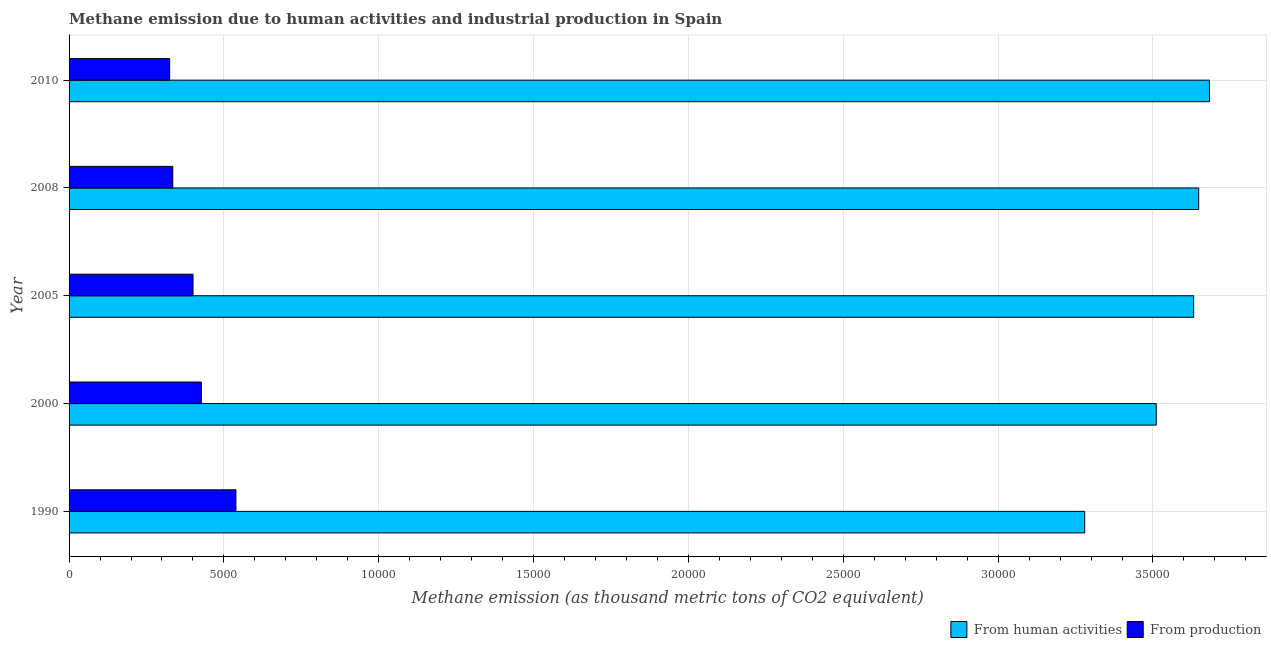Are the number of bars per tick equal to the number of legend labels?
Your answer should be compact. Yes. Are the number of bars on each tick of the Y-axis equal?
Keep it short and to the point. Yes. How many bars are there on the 5th tick from the bottom?
Your answer should be very brief. 2. What is the label of the 5th group of bars from the top?
Provide a short and direct response. 1990. In how many cases, is the number of bars for a given year not equal to the number of legend labels?
Ensure brevity in your answer.  0. What is the amount of emissions from human activities in 2000?
Provide a short and direct response. 3.51e+04. Across all years, what is the maximum amount of emissions from human activities?
Ensure brevity in your answer.  3.68e+04. Across all years, what is the minimum amount of emissions generated from industries?
Make the answer very short. 3248.1. In which year was the amount of emissions from human activities maximum?
Your response must be concise. 2010. In which year was the amount of emissions from human activities minimum?
Ensure brevity in your answer.  1990. What is the total amount of emissions from human activities in the graph?
Offer a terse response. 1.78e+05. What is the difference between the amount of emissions from human activities in 2005 and that in 2010?
Your answer should be very brief. -510. What is the difference between the amount of emissions from human activities in 2008 and the amount of emissions generated from industries in 2010?
Keep it short and to the point. 3.32e+04. What is the average amount of emissions from human activities per year?
Ensure brevity in your answer.  3.55e+04. In the year 2000, what is the difference between the amount of emissions generated from industries and amount of emissions from human activities?
Your answer should be very brief. -3.08e+04. In how many years, is the amount of emissions generated from industries greater than 21000 thousand metric tons?
Ensure brevity in your answer.  0. Is the amount of emissions generated from industries in 2000 less than that in 2008?
Your response must be concise. No. What is the difference between the highest and the second highest amount of emissions generated from industries?
Provide a succinct answer. 1116.8. What is the difference between the highest and the lowest amount of emissions generated from industries?
Provide a short and direct response. 2139.7. In how many years, is the amount of emissions from human activities greater than the average amount of emissions from human activities taken over all years?
Make the answer very short. 3. What does the 1st bar from the top in 2010 represents?
Ensure brevity in your answer.  From production. What does the 1st bar from the bottom in 2010 represents?
Keep it short and to the point. From human activities. How many years are there in the graph?
Your answer should be very brief. 5. What is the difference between two consecutive major ticks on the X-axis?
Provide a short and direct response. 5000. Does the graph contain any zero values?
Your answer should be very brief. No. Does the graph contain grids?
Make the answer very short. Yes. How many legend labels are there?
Offer a very short reply. 2. How are the legend labels stacked?
Offer a very short reply. Horizontal. What is the title of the graph?
Your answer should be very brief. Methane emission due to human activities and industrial production in Spain. What is the label or title of the X-axis?
Ensure brevity in your answer.  Methane emission (as thousand metric tons of CO2 equivalent). What is the Methane emission (as thousand metric tons of CO2 equivalent) of From human activities in 1990?
Ensure brevity in your answer.  3.28e+04. What is the Methane emission (as thousand metric tons of CO2 equivalent) in From production in 1990?
Give a very brief answer. 5387.8. What is the Methane emission (as thousand metric tons of CO2 equivalent) in From human activities in 2000?
Offer a very short reply. 3.51e+04. What is the Methane emission (as thousand metric tons of CO2 equivalent) of From production in 2000?
Your response must be concise. 4271. What is the Methane emission (as thousand metric tons of CO2 equivalent) of From human activities in 2005?
Your answer should be compact. 3.63e+04. What is the Methane emission (as thousand metric tons of CO2 equivalent) of From production in 2005?
Make the answer very short. 4002.6. What is the Methane emission (as thousand metric tons of CO2 equivalent) in From human activities in 2008?
Make the answer very short. 3.65e+04. What is the Methane emission (as thousand metric tons of CO2 equivalent) in From production in 2008?
Provide a succinct answer. 3348.1. What is the Methane emission (as thousand metric tons of CO2 equivalent) in From human activities in 2010?
Offer a very short reply. 3.68e+04. What is the Methane emission (as thousand metric tons of CO2 equivalent) in From production in 2010?
Keep it short and to the point. 3248.1. Across all years, what is the maximum Methane emission (as thousand metric tons of CO2 equivalent) of From human activities?
Offer a very short reply. 3.68e+04. Across all years, what is the maximum Methane emission (as thousand metric tons of CO2 equivalent) in From production?
Your response must be concise. 5387.8. Across all years, what is the minimum Methane emission (as thousand metric tons of CO2 equivalent) in From human activities?
Ensure brevity in your answer.  3.28e+04. Across all years, what is the minimum Methane emission (as thousand metric tons of CO2 equivalent) in From production?
Offer a very short reply. 3248.1. What is the total Methane emission (as thousand metric tons of CO2 equivalent) in From human activities in the graph?
Keep it short and to the point. 1.78e+05. What is the total Methane emission (as thousand metric tons of CO2 equivalent) in From production in the graph?
Provide a short and direct response. 2.03e+04. What is the difference between the Methane emission (as thousand metric tons of CO2 equivalent) in From human activities in 1990 and that in 2000?
Keep it short and to the point. -2310.4. What is the difference between the Methane emission (as thousand metric tons of CO2 equivalent) in From production in 1990 and that in 2000?
Ensure brevity in your answer.  1116.8. What is the difference between the Methane emission (as thousand metric tons of CO2 equivalent) in From human activities in 1990 and that in 2005?
Ensure brevity in your answer.  -3519.1. What is the difference between the Methane emission (as thousand metric tons of CO2 equivalent) of From production in 1990 and that in 2005?
Provide a succinct answer. 1385.2. What is the difference between the Methane emission (as thousand metric tons of CO2 equivalent) in From human activities in 1990 and that in 2008?
Ensure brevity in your answer.  -3681.4. What is the difference between the Methane emission (as thousand metric tons of CO2 equivalent) of From production in 1990 and that in 2008?
Make the answer very short. 2039.7. What is the difference between the Methane emission (as thousand metric tons of CO2 equivalent) of From human activities in 1990 and that in 2010?
Your answer should be very brief. -4029.1. What is the difference between the Methane emission (as thousand metric tons of CO2 equivalent) of From production in 1990 and that in 2010?
Give a very brief answer. 2139.7. What is the difference between the Methane emission (as thousand metric tons of CO2 equivalent) in From human activities in 2000 and that in 2005?
Your response must be concise. -1208.7. What is the difference between the Methane emission (as thousand metric tons of CO2 equivalent) in From production in 2000 and that in 2005?
Offer a very short reply. 268.4. What is the difference between the Methane emission (as thousand metric tons of CO2 equivalent) in From human activities in 2000 and that in 2008?
Provide a succinct answer. -1371. What is the difference between the Methane emission (as thousand metric tons of CO2 equivalent) in From production in 2000 and that in 2008?
Your response must be concise. 922.9. What is the difference between the Methane emission (as thousand metric tons of CO2 equivalent) of From human activities in 2000 and that in 2010?
Your response must be concise. -1718.7. What is the difference between the Methane emission (as thousand metric tons of CO2 equivalent) in From production in 2000 and that in 2010?
Keep it short and to the point. 1022.9. What is the difference between the Methane emission (as thousand metric tons of CO2 equivalent) in From human activities in 2005 and that in 2008?
Keep it short and to the point. -162.3. What is the difference between the Methane emission (as thousand metric tons of CO2 equivalent) in From production in 2005 and that in 2008?
Provide a succinct answer. 654.5. What is the difference between the Methane emission (as thousand metric tons of CO2 equivalent) in From human activities in 2005 and that in 2010?
Ensure brevity in your answer.  -510. What is the difference between the Methane emission (as thousand metric tons of CO2 equivalent) in From production in 2005 and that in 2010?
Provide a succinct answer. 754.5. What is the difference between the Methane emission (as thousand metric tons of CO2 equivalent) of From human activities in 2008 and that in 2010?
Provide a short and direct response. -347.7. What is the difference between the Methane emission (as thousand metric tons of CO2 equivalent) in From human activities in 1990 and the Methane emission (as thousand metric tons of CO2 equivalent) in From production in 2000?
Your response must be concise. 2.85e+04. What is the difference between the Methane emission (as thousand metric tons of CO2 equivalent) in From human activities in 1990 and the Methane emission (as thousand metric tons of CO2 equivalent) in From production in 2005?
Provide a succinct answer. 2.88e+04. What is the difference between the Methane emission (as thousand metric tons of CO2 equivalent) of From human activities in 1990 and the Methane emission (as thousand metric tons of CO2 equivalent) of From production in 2008?
Provide a succinct answer. 2.94e+04. What is the difference between the Methane emission (as thousand metric tons of CO2 equivalent) of From human activities in 1990 and the Methane emission (as thousand metric tons of CO2 equivalent) of From production in 2010?
Your answer should be compact. 2.95e+04. What is the difference between the Methane emission (as thousand metric tons of CO2 equivalent) of From human activities in 2000 and the Methane emission (as thousand metric tons of CO2 equivalent) of From production in 2005?
Give a very brief answer. 3.11e+04. What is the difference between the Methane emission (as thousand metric tons of CO2 equivalent) in From human activities in 2000 and the Methane emission (as thousand metric tons of CO2 equivalent) in From production in 2008?
Your response must be concise. 3.18e+04. What is the difference between the Methane emission (as thousand metric tons of CO2 equivalent) of From human activities in 2000 and the Methane emission (as thousand metric tons of CO2 equivalent) of From production in 2010?
Your answer should be compact. 3.19e+04. What is the difference between the Methane emission (as thousand metric tons of CO2 equivalent) of From human activities in 2005 and the Methane emission (as thousand metric tons of CO2 equivalent) of From production in 2008?
Make the answer very short. 3.30e+04. What is the difference between the Methane emission (as thousand metric tons of CO2 equivalent) in From human activities in 2005 and the Methane emission (as thousand metric tons of CO2 equivalent) in From production in 2010?
Keep it short and to the point. 3.31e+04. What is the difference between the Methane emission (as thousand metric tons of CO2 equivalent) of From human activities in 2008 and the Methane emission (as thousand metric tons of CO2 equivalent) of From production in 2010?
Your answer should be compact. 3.32e+04. What is the average Methane emission (as thousand metric tons of CO2 equivalent) of From human activities per year?
Ensure brevity in your answer.  3.55e+04. What is the average Methane emission (as thousand metric tons of CO2 equivalent) in From production per year?
Make the answer very short. 4051.52. In the year 1990, what is the difference between the Methane emission (as thousand metric tons of CO2 equivalent) in From human activities and Methane emission (as thousand metric tons of CO2 equivalent) in From production?
Provide a succinct answer. 2.74e+04. In the year 2000, what is the difference between the Methane emission (as thousand metric tons of CO2 equivalent) in From human activities and Methane emission (as thousand metric tons of CO2 equivalent) in From production?
Your answer should be compact. 3.08e+04. In the year 2005, what is the difference between the Methane emission (as thousand metric tons of CO2 equivalent) of From human activities and Methane emission (as thousand metric tons of CO2 equivalent) of From production?
Provide a succinct answer. 3.23e+04. In the year 2008, what is the difference between the Methane emission (as thousand metric tons of CO2 equivalent) in From human activities and Methane emission (as thousand metric tons of CO2 equivalent) in From production?
Your response must be concise. 3.31e+04. In the year 2010, what is the difference between the Methane emission (as thousand metric tons of CO2 equivalent) in From human activities and Methane emission (as thousand metric tons of CO2 equivalent) in From production?
Your answer should be compact. 3.36e+04. What is the ratio of the Methane emission (as thousand metric tons of CO2 equivalent) in From human activities in 1990 to that in 2000?
Offer a very short reply. 0.93. What is the ratio of the Methane emission (as thousand metric tons of CO2 equivalent) in From production in 1990 to that in 2000?
Your response must be concise. 1.26. What is the ratio of the Methane emission (as thousand metric tons of CO2 equivalent) in From human activities in 1990 to that in 2005?
Give a very brief answer. 0.9. What is the ratio of the Methane emission (as thousand metric tons of CO2 equivalent) in From production in 1990 to that in 2005?
Offer a very short reply. 1.35. What is the ratio of the Methane emission (as thousand metric tons of CO2 equivalent) of From human activities in 1990 to that in 2008?
Offer a terse response. 0.9. What is the ratio of the Methane emission (as thousand metric tons of CO2 equivalent) of From production in 1990 to that in 2008?
Ensure brevity in your answer.  1.61. What is the ratio of the Methane emission (as thousand metric tons of CO2 equivalent) in From human activities in 1990 to that in 2010?
Your answer should be very brief. 0.89. What is the ratio of the Methane emission (as thousand metric tons of CO2 equivalent) of From production in 1990 to that in 2010?
Your response must be concise. 1.66. What is the ratio of the Methane emission (as thousand metric tons of CO2 equivalent) of From human activities in 2000 to that in 2005?
Provide a short and direct response. 0.97. What is the ratio of the Methane emission (as thousand metric tons of CO2 equivalent) of From production in 2000 to that in 2005?
Your answer should be very brief. 1.07. What is the ratio of the Methane emission (as thousand metric tons of CO2 equivalent) in From human activities in 2000 to that in 2008?
Offer a very short reply. 0.96. What is the ratio of the Methane emission (as thousand metric tons of CO2 equivalent) in From production in 2000 to that in 2008?
Ensure brevity in your answer.  1.28. What is the ratio of the Methane emission (as thousand metric tons of CO2 equivalent) of From human activities in 2000 to that in 2010?
Provide a short and direct response. 0.95. What is the ratio of the Methane emission (as thousand metric tons of CO2 equivalent) of From production in 2000 to that in 2010?
Provide a succinct answer. 1.31. What is the ratio of the Methane emission (as thousand metric tons of CO2 equivalent) of From production in 2005 to that in 2008?
Your answer should be compact. 1.2. What is the ratio of the Methane emission (as thousand metric tons of CO2 equivalent) in From human activities in 2005 to that in 2010?
Your answer should be compact. 0.99. What is the ratio of the Methane emission (as thousand metric tons of CO2 equivalent) in From production in 2005 to that in 2010?
Make the answer very short. 1.23. What is the ratio of the Methane emission (as thousand metric tons of CO2 equivalent) of From human activities in 2008 to that in 2010?
Provide a succinct answer. 0.99. What is the ratio of the Methane emission (as thousand metric tons of CO2 equivalent) in From production in 2008 to that in 2010?
Give a very brief answer. 1.03. What is the difference between the highest and the second highest Methane emission (as thousand metric tons of CO2 equivalent) in From human activities?
Your answer should be very brief. 347.7. What is the difference between the highest and the second highest Methane emission (as thousand metric tons of CO2 equivalent) of From production?
Offer a terse response. 1116.8. What is the difference between the highest and the lowest Methane emission (as thousand metric tons of CO2 equivalent) in From human activities?
Provide a succinct answer. 4029.1. What is the difference between the highest and the lowest Methane emission (as thousand metric tons of CO2 equivalent) in From production?
Keep it short and to the point. 2139.7. 